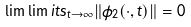<formula> <loc_0><loc_0><loc_500><loc_500>\lim \lim i t s _ { t \rightarrow \infty } \| \phi _ { 2 } ( \cdot , t ) \| = 0</formula> 